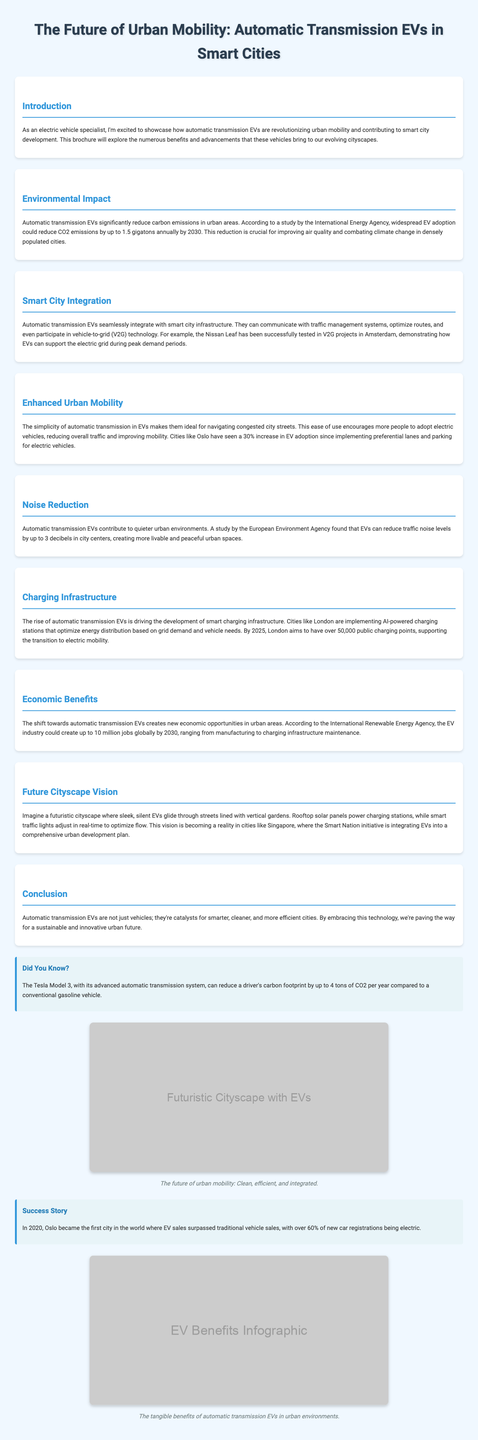What is the title of the brochure? The title is stated at the top of the document, highlighting the focus on urban mobility and automatic transmission EVs.
Answer: The Future of Urban Mobility: Automatic Transmission EVs in Smart Cities How much could EV adoption reduce CO2 emissions annually by 2030? This figure is provided in the Environmental Impact section, indicating the potential reduction in emissions from EVs.
Answer: up to 1.5 gigatons What is the main role of automatic transmission EVs in smart city infrastructure? The document states that these EVs can communicate with traffic management systems and optimize routes, showing their integration with smart cities.
Answer: Seamless integration By how much can automatic transmission EVs reduce traffic noise levels? This specific reduction in noise levels is noted in the Noise Reduction section, showcasing the improvements in urban environments.
Answer: up to 3 decibels Which city aims to have over 50,000 public charging points by 2025? The Charging Infrastructure section mentions this city in relation to the development of smart charging infrastructure for EVs.
Answer: London What percentage increase in EV adoption did Oslo see after implementing preferential lanes? This percentage is provided as an example of successful urban mobility changes due to EV initiatives.
Answer: 30% What is the envisioned future cityscape characterized by? The Future Cityscape Vision section describes various features of an idealized urban setting with EVs and sustainability aspects.
Answer: Sleek, silent EVs and vertical gardens What job creation potential does the EV industry have by 2030 according to the document? This number reflects the expected economic benefits of the shift to automatic transmission EVs in urban settings.
Answer: up to 10 million jobs 